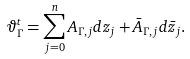<formula> <loc_0><loc_0><loc_500><loc_500>\vartheta ^ { t } _ { \Gamma } = \sum _ { j = 0 } ^ { n } A _ { \Gamma , j } d z _ { j } + \bar { A } _ { \Gamma , j } d \bar { z } _ { j } .</formula> 